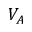<formula> <loc_0><loc_0><loc_500><loc_500>V _ { A }</formula> 